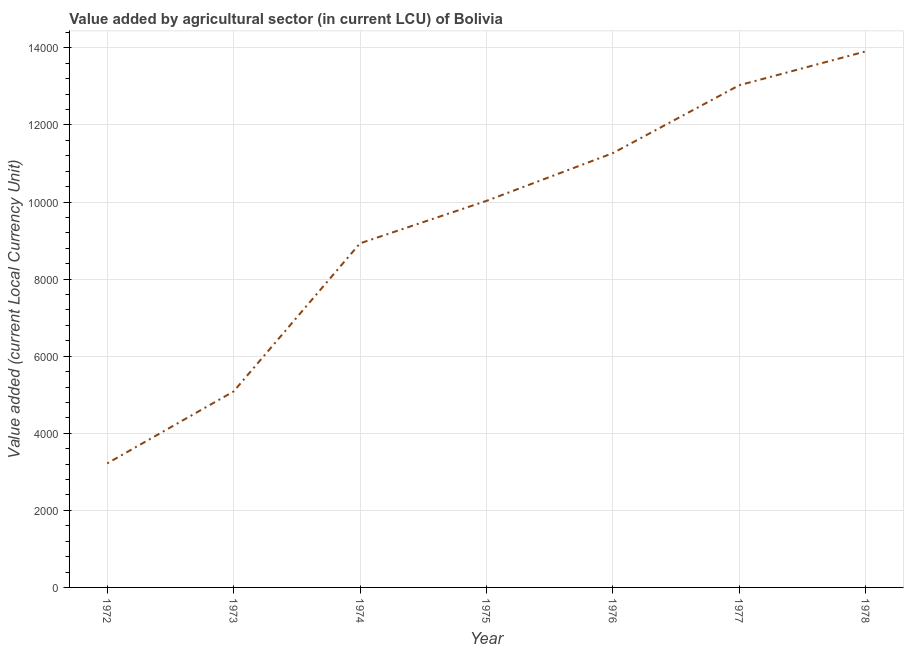What is the value added by agriculture sector in 1976?
Your response must be concise. 1.13e+04. Across all years, what is the maximum value added by agriculture sector?
Ensure brevity in your answer.  1.39e+04. Across all years, what is the minimum value added by agriculture sector?
Give a very brief answer. 3219. In which year was the value added by agriculture sector maximum?
Give a very brief answer. 1978. What is the sum of the value added by agriculture sector?
Give a very brief answer. 6.55e+04. What is the difference between the value added by agriculture sector in 1974 and 1977?
Give a very brief answer. -4102. What is the average value added by agriculture sector per year?
Your response must be concise. 9353.14. What is the median value added by agriculture sector?
Your answer should be very brief. 1.00e+04. What is the ratio of the value added by agriculture sector in 1972 to that in 1978?
Your response must be concise. 0.23. Is the value added by agriculture sector in 1973 less than that in 1976?
Ensure brevity in your answer.  Yes. Is the difference between the value added by agriculture sector in 1972 and 1975 greater than the difference between any two years?
Make the answer very short. No. What is the difference between the highest and the second highest value added by agriculture sector?
Give a very brief answer. 878. Is the sum of the value added by agriculture sector in 1976 and 1978 greater than the maximum value added by agriculture sector across all years?
Make the answer very short. Yes. What is the difference between the highest and the lowest value added by agriculture sector?
Ensure brevity in your answer.  1.07e+04. Does the value added by agriculture sector monotonically increase over the years?
Provide a succinct answer. Yes. What is the difference between two consecutive major ticks on the Y-axis?
Keep it short and to the point. 2000. What is the title of the graph?
Offer a terse response. Value added by agricultural sector (in current LCU) of Bolivia. What is the label or title of the X-axis?
Your answer should be very brief. Year. What is the label or title of the Y-axis?
Your answer should be compact. Value added (current Local Currency Unit). What is the Value added (current Local Currency Unit) in 1972?
Provide a succinct answer. 3219. What is the Value added (current Local Currency Unit) of 1973?
Your answer should be very brief. 5085. What is the Value added (current Local Currency Unit) of 1974?
Make the answer very short. 8929. What is the Value added (current Local Currency Unit) in 1975?
Provide a succinct answer. 1.00e+04. What is the Value added (current Local Currency Unit) of 1976?
Give a very brief answer. 1.13e+04. What is the Value added (current Local Currency Unit) of 1977?
Your answer should be very brief. 1.30e+04. What is the Value added (current Local Currency Unit) of 1978?
Give a very brief answer. 1.39e+04. What is the difference between the Value added (current Local Currency Unit) in 1972 and 1973?
Your response must be concise. -1866. What is the difference between the Value added (current Local Currency Unit) in 1972 and 1974?
Your response must be concise. -5710. What is the difference between the Value added (current Local Currency Unit) in 1972 and 1975?
Ensure brevity in your answer.  -6811. What is the difference between the Value added (current Local Currency Unit) in 1972 and 1976?
Keep it short and to the point. -8050. What is the difference between the Value added (current Local Currency Unit) in 1972 and 1977?
Keep it short and to the point. -9812. What is the difference between the Value added (current Local Currency Unit) in 1972 and 1978?
Provide a short and direct response. -1.07e+04. What is the difference between the Value added (current Local Currency Unit) in 1973 and 1974?
Your response must be concise. -3844. What is the difference between the Value added (current Local Currency Unit) in 1973 and 1975?
Your response must be concise. -4945. What is the difference between the Value added (current Local Currency Unit) in 1973 and 1976?
Keep it short and to the point. -6184. What is the difference between the Value added (current Local Currency Unit) in 1973 and 1977?
Make the answer very short. -7946. What is the difference between the Value added (current Local Currency Unit) in 1973 and 1978?
Keep it short and to the point. -8824. What is the difference between the Value added (current Local Currency Unit) in 1974 and 1975?
Keep it short and to the point. -1101. What is the difference between the Value added (current Local Currency Unit) in 1974 and 1976?
Provide a short and direct response. -2340. What is the difference between the Value added (current Local Currency Unit) in 1974 and 1977?
Offer a very short reply. -4102. What is the difference between the Value added (current Local Currency Unit) in 1974 and 1978?
Make the answer very short. -4980. What is the difference between the Value added (current Local Currency Unit) in 1975 and 1976?
Provide a succinct answer. -1239. What is the difference between the Value added (current Local Currency Unit) in 1975 and 1977?
Provide a short and direct response. -3001. What is the difference between the Value added (current Local Currency Unit) in 1975 and 1978?
Your answer should be compact. -3879. What is the difference between the Value added (current Local Currency Unit) in 1976 and 1977?
Your answer should be very brief. -1762. What is the difference between the Value added (current Local Currency Unit) in 1976 and 1978?
Your response must be concise. -2640. What is the difference between the Value added (current Local Currency Unit) in 1977 and 1978?
Make the answer very short. -878. What is the ratio of the Value added (current Local Currency Unit) in 1972 to that in 1973?
Your answer should be very brief. 0.63. What is the ratio of the Value added (current Local Currency Unit) in 1972 to that in 1974?
Your response must be concise. 0.36. What is the ratio of the Value added (current Local Currency Unit) in 1972 to that in 1975?
Provide a succinct answer. 0.32. What is the ratio of the Value added (current Local Currency Unit) in 1972 to that in 1976?
Give a very brief answer. 0.29. What is the ratio of the Value added (current Local Currency Unit) in 1972 to that in 1977?
Your response must be concise. 0.25. What is the ratio of the Value added (current Local Currency Unit) in 1972 to that in 1978?
Keep it short and to the point. 0.23. What is the ratio of the Value added (current Local Currency Unit) in 1973 to that in 1974?
Make the answer very short. 0.57. What is the ratio of the Value added (current Local Currency Unit) in 1973 to that in 1975?
Your response must be concise. 0.51. What is the ratio of the Value added (current Local Currency Unit) in 1973 to that in 1976?
Your response must be concise. 0.45. What is the ratio of the Value added (current Local Currency Unit) in 1973 to that in 1977?
Offer a terse response. 0.39. What is the ratio of the Value added (current Local Currency Unit) in 1973 to that in 1978?
Give a very brief answer. 0.37. What is the ratio of the Value added (current Local Currency Unit) in 1974 to that in 1975?
Offer a very short reply. 0.89. What is the ratio of the Value added (current Local Currency Unit) in 1974 to that in 1976?
Your response must be concise. 0.79. What is the ratio of the Value added (current Local Currency Unit) in 1974 to that in 1977?
Provide a short and direct response. 0.69. What is the ratio of the Value added (current Local Currency Unit) in 1974 to that in 1978?
Provide a short and direct response. 0.64. What is the ratio of the Value added (current Local Currency Unit) in 1975 to that in 1976?
Your answer should be very brief. 0.89. What is the ratio of the Value added (current Local Currency Unit) in 1975 to that in 1977?
Your answer should be very brief. 0.77. What is the ratio of the Value added (current Local Currency Unit) in 1975 to that in 1978?
Your response must be concise. 0.72. What is the ratio of the Value added (current Local Currency Unit) in 1976 to that in 1977?
Keep it short and to the point. 0.86. What is the ratio of the Value added (current Local Currency Unit) in 1976 to that in 1978?
Provide a short and direct response. 0.81. What is the ratio of the Value added (current Local Currency Unit) in 1977 to that in 1978?
Make the answer very short. 0.94. 